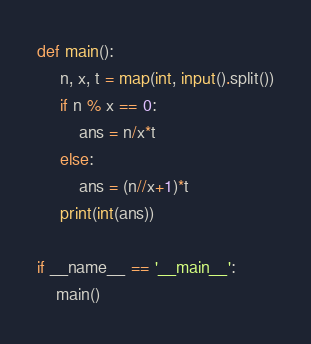Convert code to text. <code><loc_0><loc_0><loc_500><loc_500><_Python_>def main():
     n, x, t = map(int, input().split())
     if n % x == 0:
         ans = n/x*t
     else:
         ans = (n//x+1)*t
     print(int(ans))

if __name__ == '__main__':
    main()</code> 